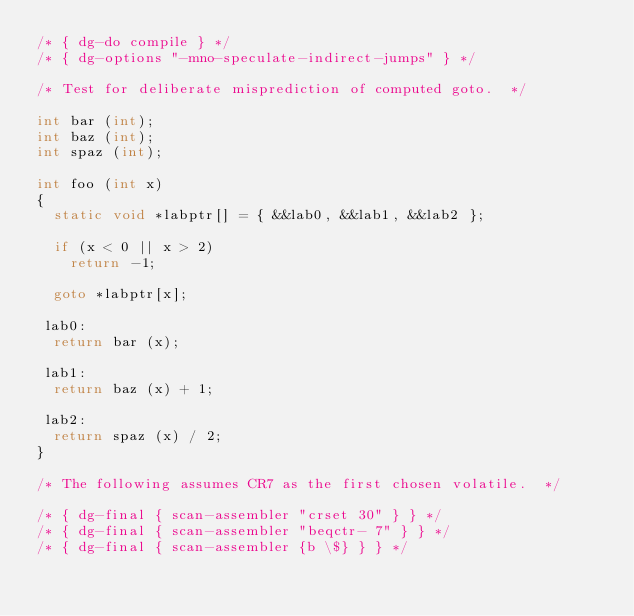Convert code to text. <code><loc_0><loc_0><loc_500><loc_500><_C_>/* { dg-do compile } */
/* { dg-options "-mno-speculate-indirect-jumps" } */

/* Test for deliberate misprediction of computed goto.  */

int bar (int);
int baz (int);
int spaz (int);

int foo (int x)
{
  static void *labptr[] = { &&lab0, &&lab1, &&lab2 };

  if (x < 0 || x > 2)
    return -1;

  goto *labptr[x];

 lab0:
  return bar (x);

 lab1:
  return baz (x) + 1;

 lab2:
  return spaz (x) / 2;
}

/* The following assumes CR7 as the first chosen volatile.  */

/* { dg-final { scan-assembler "crset 30" } } */
/* { dg-final { scan-assembler "beqctr- 7" } } */
/* { dg-final { scan-assembler {b \$} } } */
</code> 